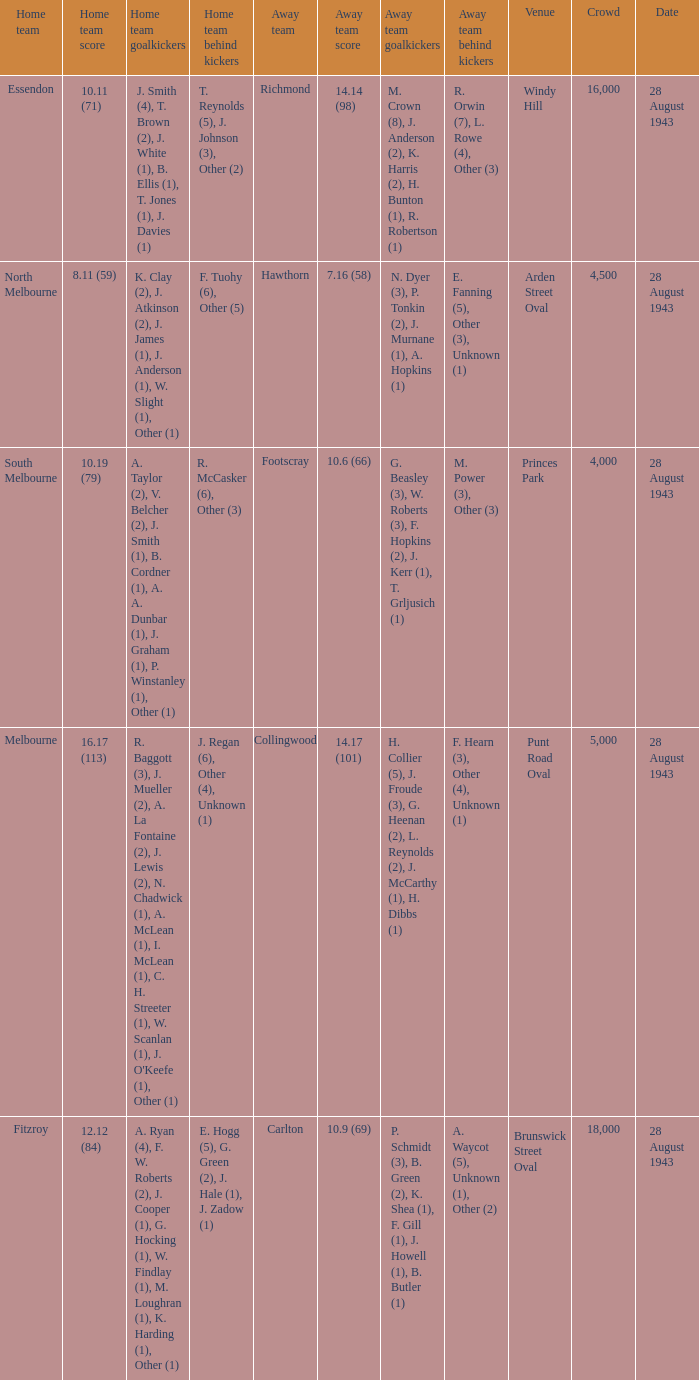What game showed a home team score of 8.11 (59)? 28 August 1943. 